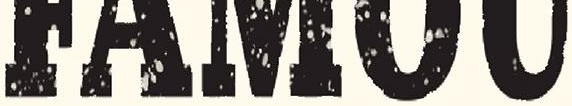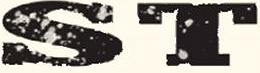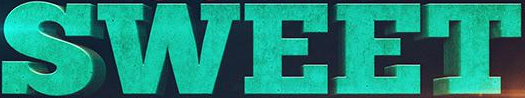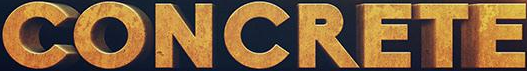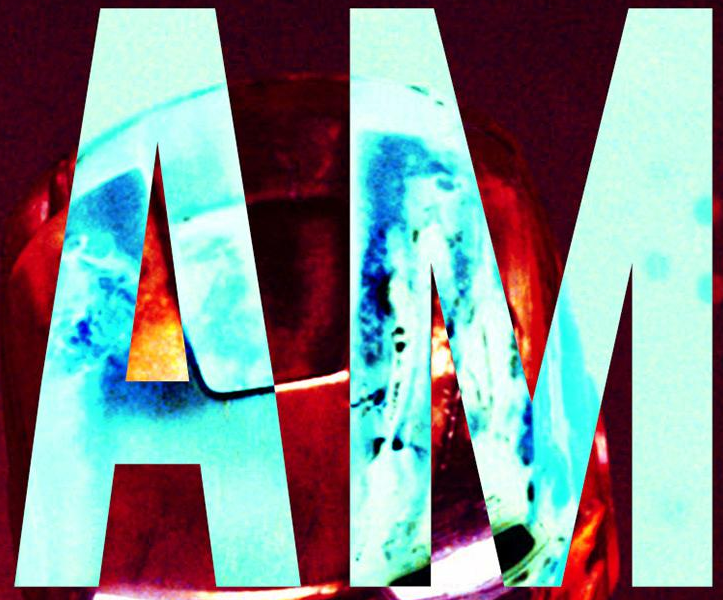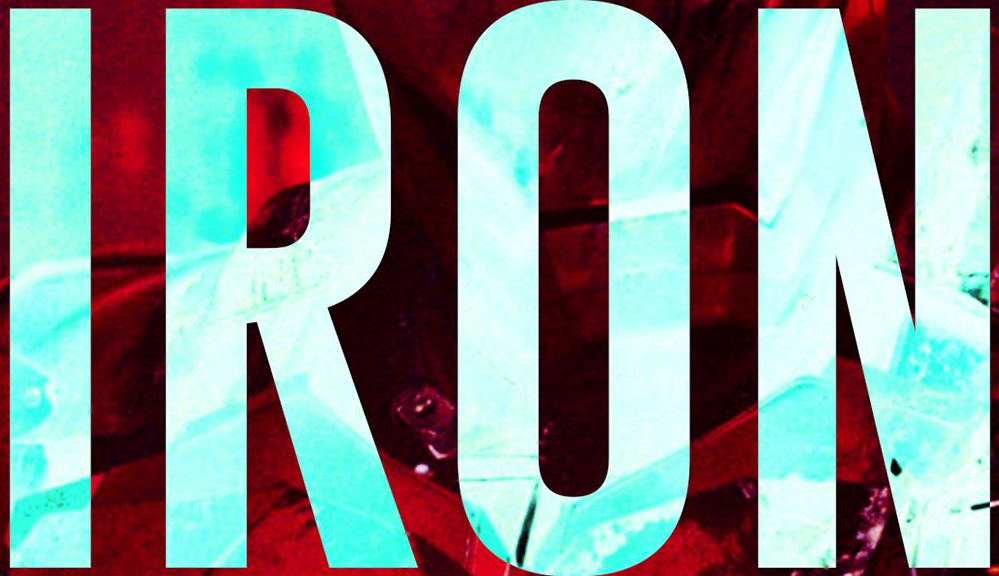What text is displayed in these images sequentially, separated by a semicolon? #####; ST; SWEET; CONCRETE; AM; IRON 